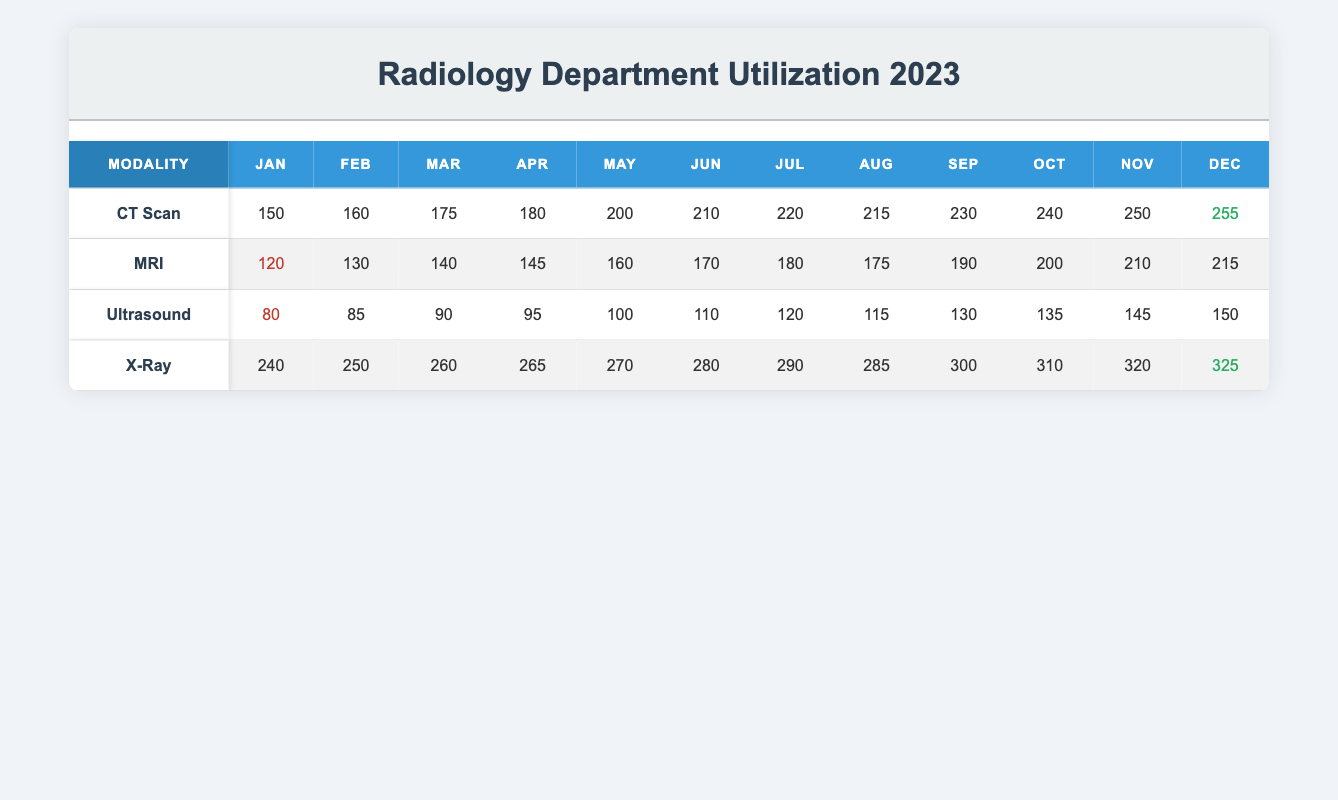What is the highest monthly utilization in December for the CT Scan? In the CT Scan row, the value for December is listed as 255. This is the highest monthly utilization value reported for this modality.
Answer: 255 What was the utilization for MRI in June? The MRI row indicates a utilization of 170 for the month of June.
Answer: 170 Which modality had the lowest utilization in January? The table shows that the Ultrasound had a utilization of 80 in January, which is lower than the other modalities: CT Scan (150), MRI (120), and X-Ray (240).
Answer: Ultrasound What is the total utilization for X-Ray from January to March? Adding the monthly utilization for X-Ray from January to March gives us 240 (Jan) + 250 (Feb) + 260 (Mar) = 750.
Answer: 750 Was the utilization for MRI higher in October than in May? The utilization for MRI in October (200) is higher than in May (160) as per the values in the table.
Answer: Yes Which modality experienced the highest increase in utilization from January to December? The differences in utilization from January to December for each modality are: CT Scan (150 to 255, increase of 105), MRI (120 to 215, increase of 95), Ultrasound (80 to 150, increase of 70), and X-Ray (240 to 325, increase of 85). X-Ray experienced the highest increase, with a total of 85.
Answer: X-Ray What is the average utilization for Ultrasound over the year? To find the average, we first sum the monthly values for Ultrasound: 80 + 85 + 90 + 95 + 100 + 110 + 120 + 115 + 130 + 135 + 145 + 150 = 1,505. Next, we divide this sum by 12 months, yielding an average of 125.42, which can be rounded to 125 when simplified.
Answer: 125 In which month did the CT Scan see its highest utilization? Reviewing the monthly utilization for CT Scan from January to December, the highest value occurs in December at 255.
Answer: December Did any modality have utilization below 100 in any month? Yes, Ultrasound had a monthly utilization below 100 in January (80) and February (85).
Answer: Yes 